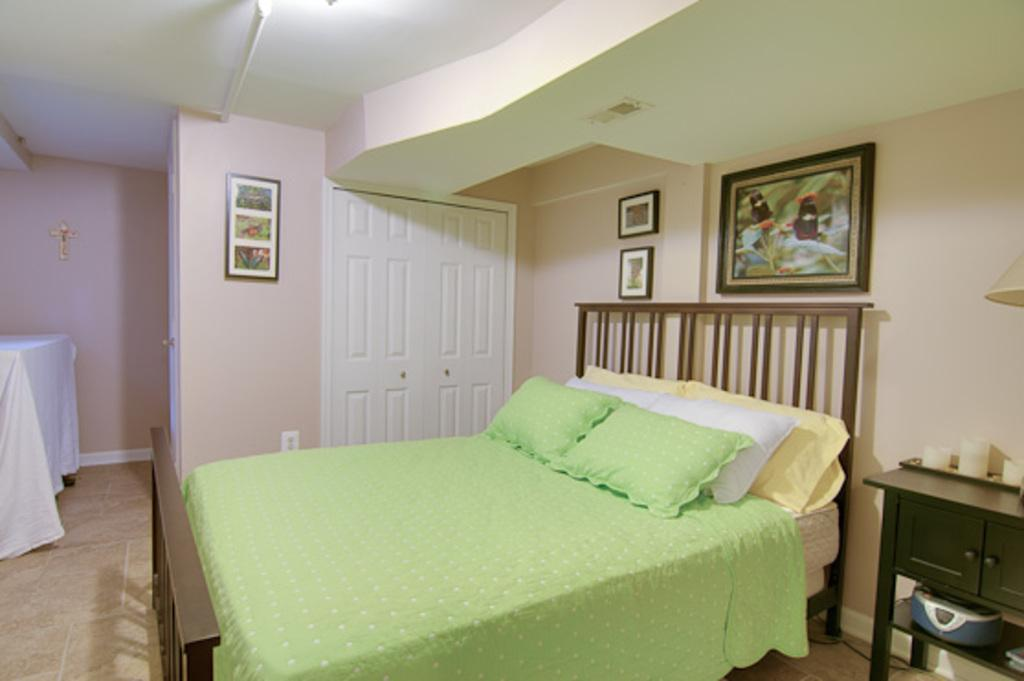What type of space is shown in the image? The image is inside a room. What furniture is present in the room? There is a bed with pillows and a table in the room. Are there any decorative items in the room? Yes, there are photo frames in the room. How many doors are visible in the image? There are doors in the room. What part of the room can be seen above the objects in the image? The ceiling is visible in the image. What type of plants are growing inside the photo frames in the image? There are no plants visible inside the photo frames in the image. What surprise can be seen happening in the room in the image? There is no surprise happening in the room in the image. 